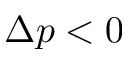<formula> <loc_0><loc_0><loc_500><loc_500>\Delta p < 0</formula> 